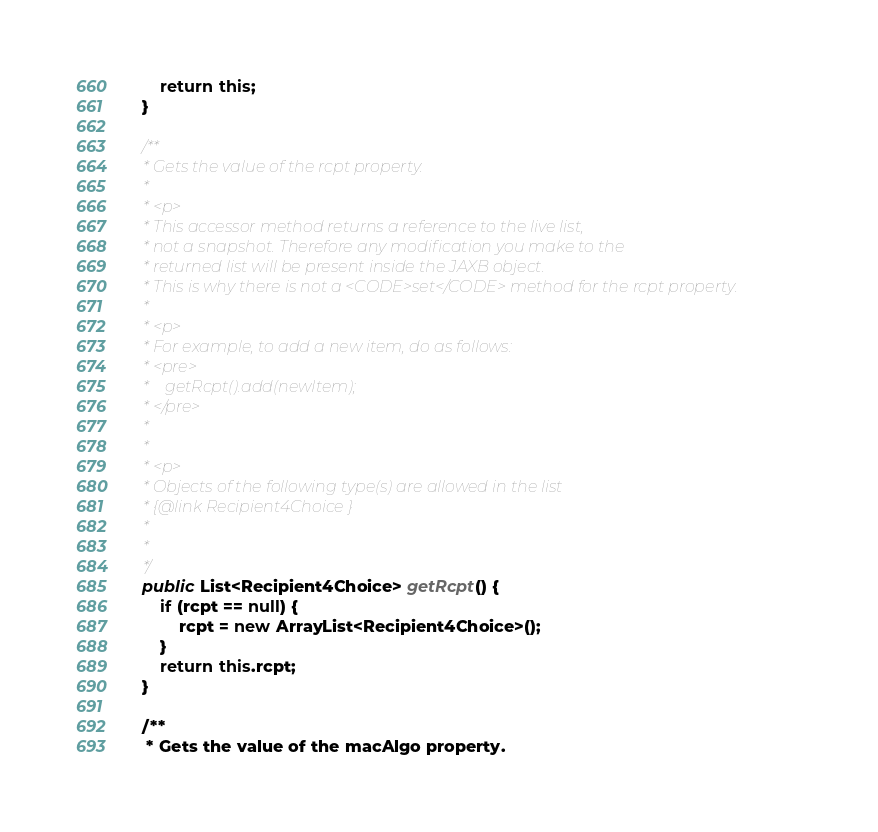<code> <loc_0><loc_0><loc_500><loc_500><_Java_>        return this;
    }

    /**
     * Gets the value of the rcpt property.
     * 
     * <p>
     * This accessor method returns a reference to the live list,
     * not a snapshot. Therefore any modification you make to the
     * returned list will be present inside the JAXB object.
     * This is why there is not a <CODE>set</CODE> method for the rcpt property.
     * 
     * <p>
     * For example, to add a new item, do as follows:
     * <pre>
     *    getRcpt().add(newItem);
     * </pre>
     * 
     * 
     * <p>
     * Objects of the following type(s) are allowed in the list
     * {@link Recipient4Choice }
     * 
     * 
     */
    public List<Recipient4Choice> getRcpt() {
        if (rcpt == null) {
            rcpt = new ArrayList<Recipient4Choice>();
        }
        return this.rcpt;
    }

    /**
     * Gets the value of the macAlgo property.</code> 